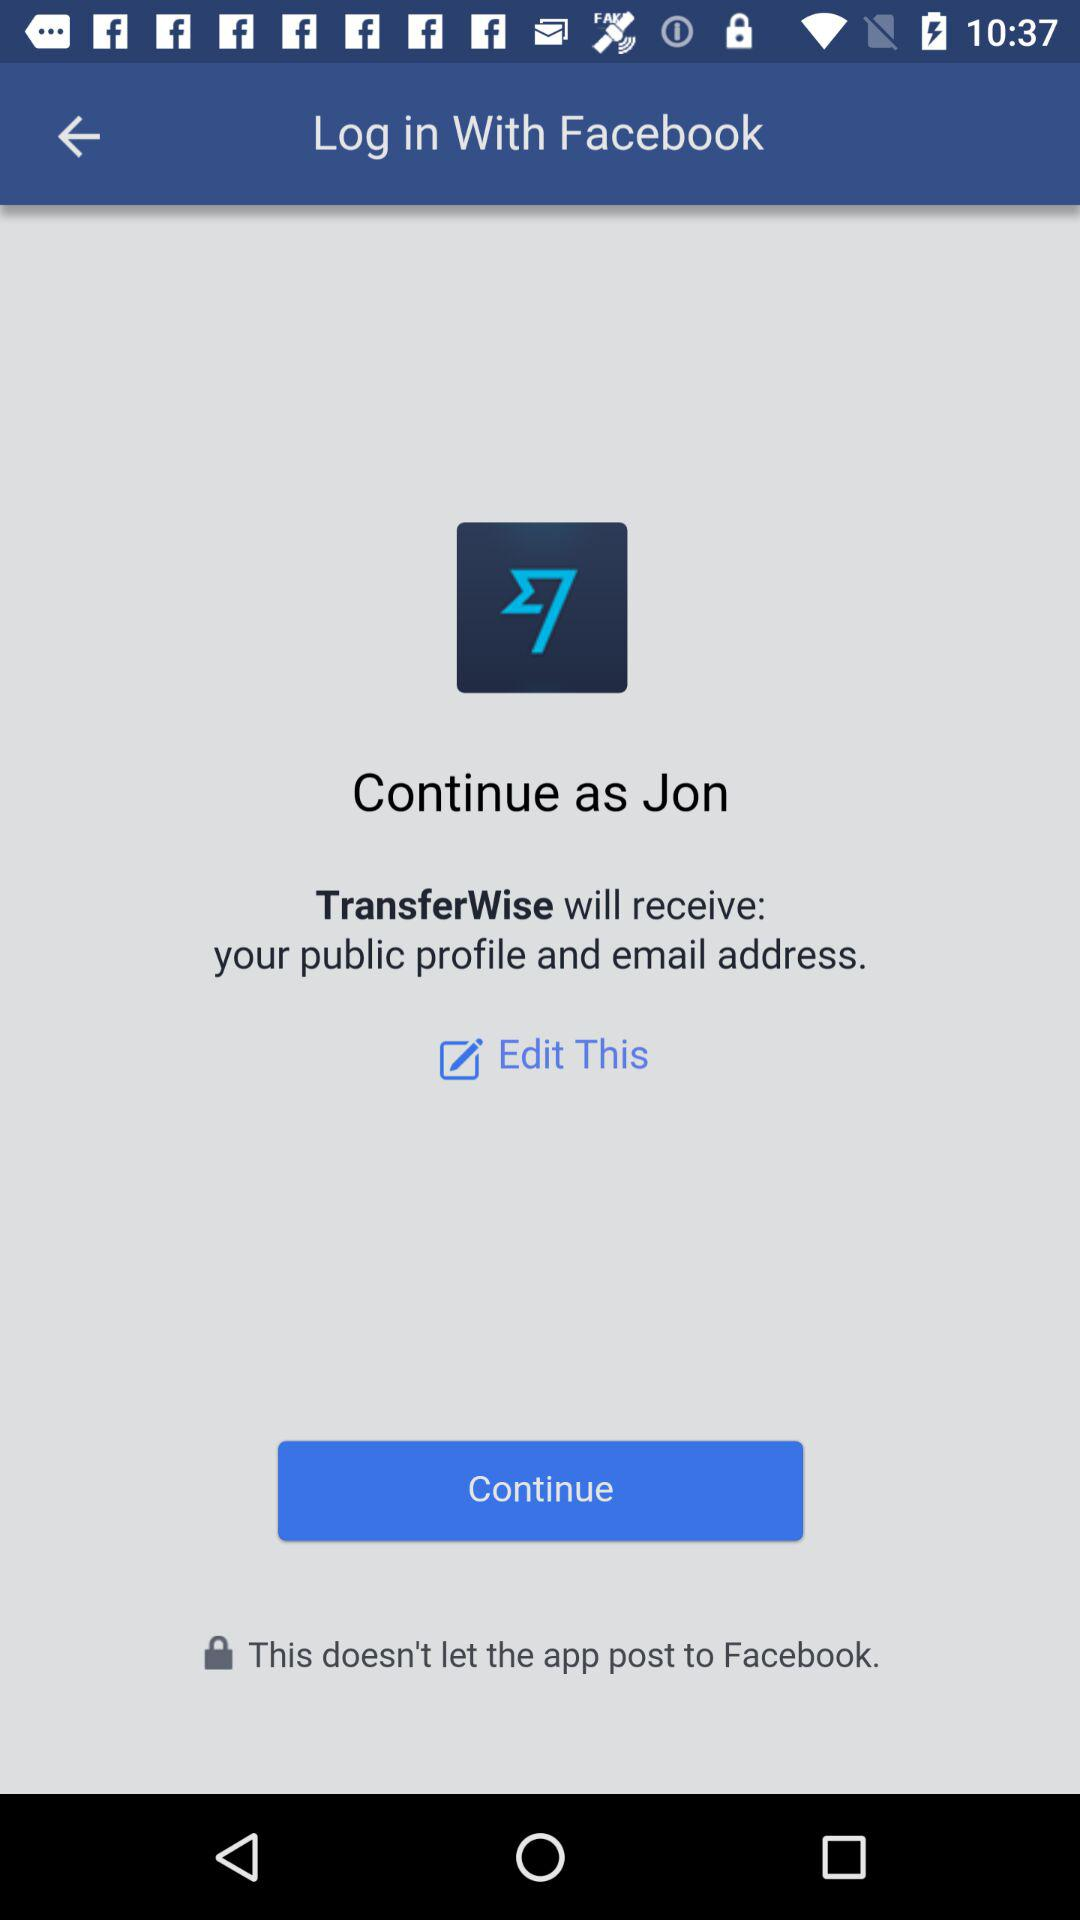What application will receive a public profile and email address? The application is "TransferWise". 